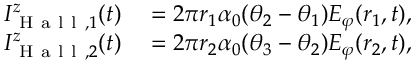Convert formula to latex. <formula><loc_0><loc_0><loc_500><loc_500>\begin{array} { r l } { I _ { H a l l , 1 } ^ { z } ( t ) } & = 2 \pi r _ { 1 } \alpha _ { 0 } ( \theta _ { 2 } - \theta _ { 1 } ) E _ { \varphi } ( r _ { 1 } , t ) , } \\ { I _ { H a l l , 2 } ^ { z } ( t ) } & = 2 \pi r _ { 2 } \alpha _ { 0 } ( \theta _ { 3 } - \theta _ { 2 } ) E _ { \varphi } ( r _ { 2 } , t ) , } \end{array}</formula> 